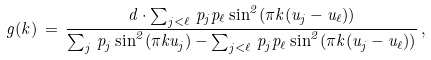<formula> <loc_0><loc_0><loc_500><loc_500>g ( k ) \, = \, \frac { d \cdot \sum _ { j < \ell } \, p _ { j } p _ { \ell } \sin ^ { 2 } ( \pi k ( u _ { j } - u _ { \ell } ) ) } { \sum _ { j } \, p _ { j } \sin ^ { 2 } ( \pi k u _ { j } ) - \sum _ { j < \ell } \, p _ { j } p _ { \ell } \sin ^ { 2 } ( \pi k ( u _ { j } - u _ { \ell } ) ) } \, ,</formula> 